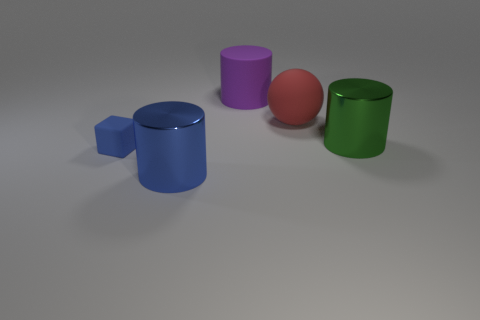Is the big green thing made of the same material as the blue thing that is behind the blue metallic object?
Your answer should be very brief. No. How many objects are yellow spheres or large matte objects?
Ensure brevity in your answer.  2. What is the material of the object that is the same color as the block?
Keep it short and to the point. Metal. Is there a big green metal thing of the same shape as the purple object?
Provide a succinct answer. Yes. How many tiny things are on the left side of the big sphere?
Make the answer very short. 1. There is a cylinder to the left of the big cylinder that is behind the green cylinder; what is it made of?
Give a very brief answer. Metal. There is a red object that is the same size as the blue metallic cylinder; what is it made of?
Your response must be concise. Rubber. Is there a green metallic object that has the same size as the red rubber thing?
Ensure brevity in your answer.  Yes. There is a metallic thing on the right side of the big blue cylinder; what is its color?
Your answer should be very brief. Green. Are there any blocks in front of the large matte object that is right of the large purple object?
Offer a very short reply. Yes. 